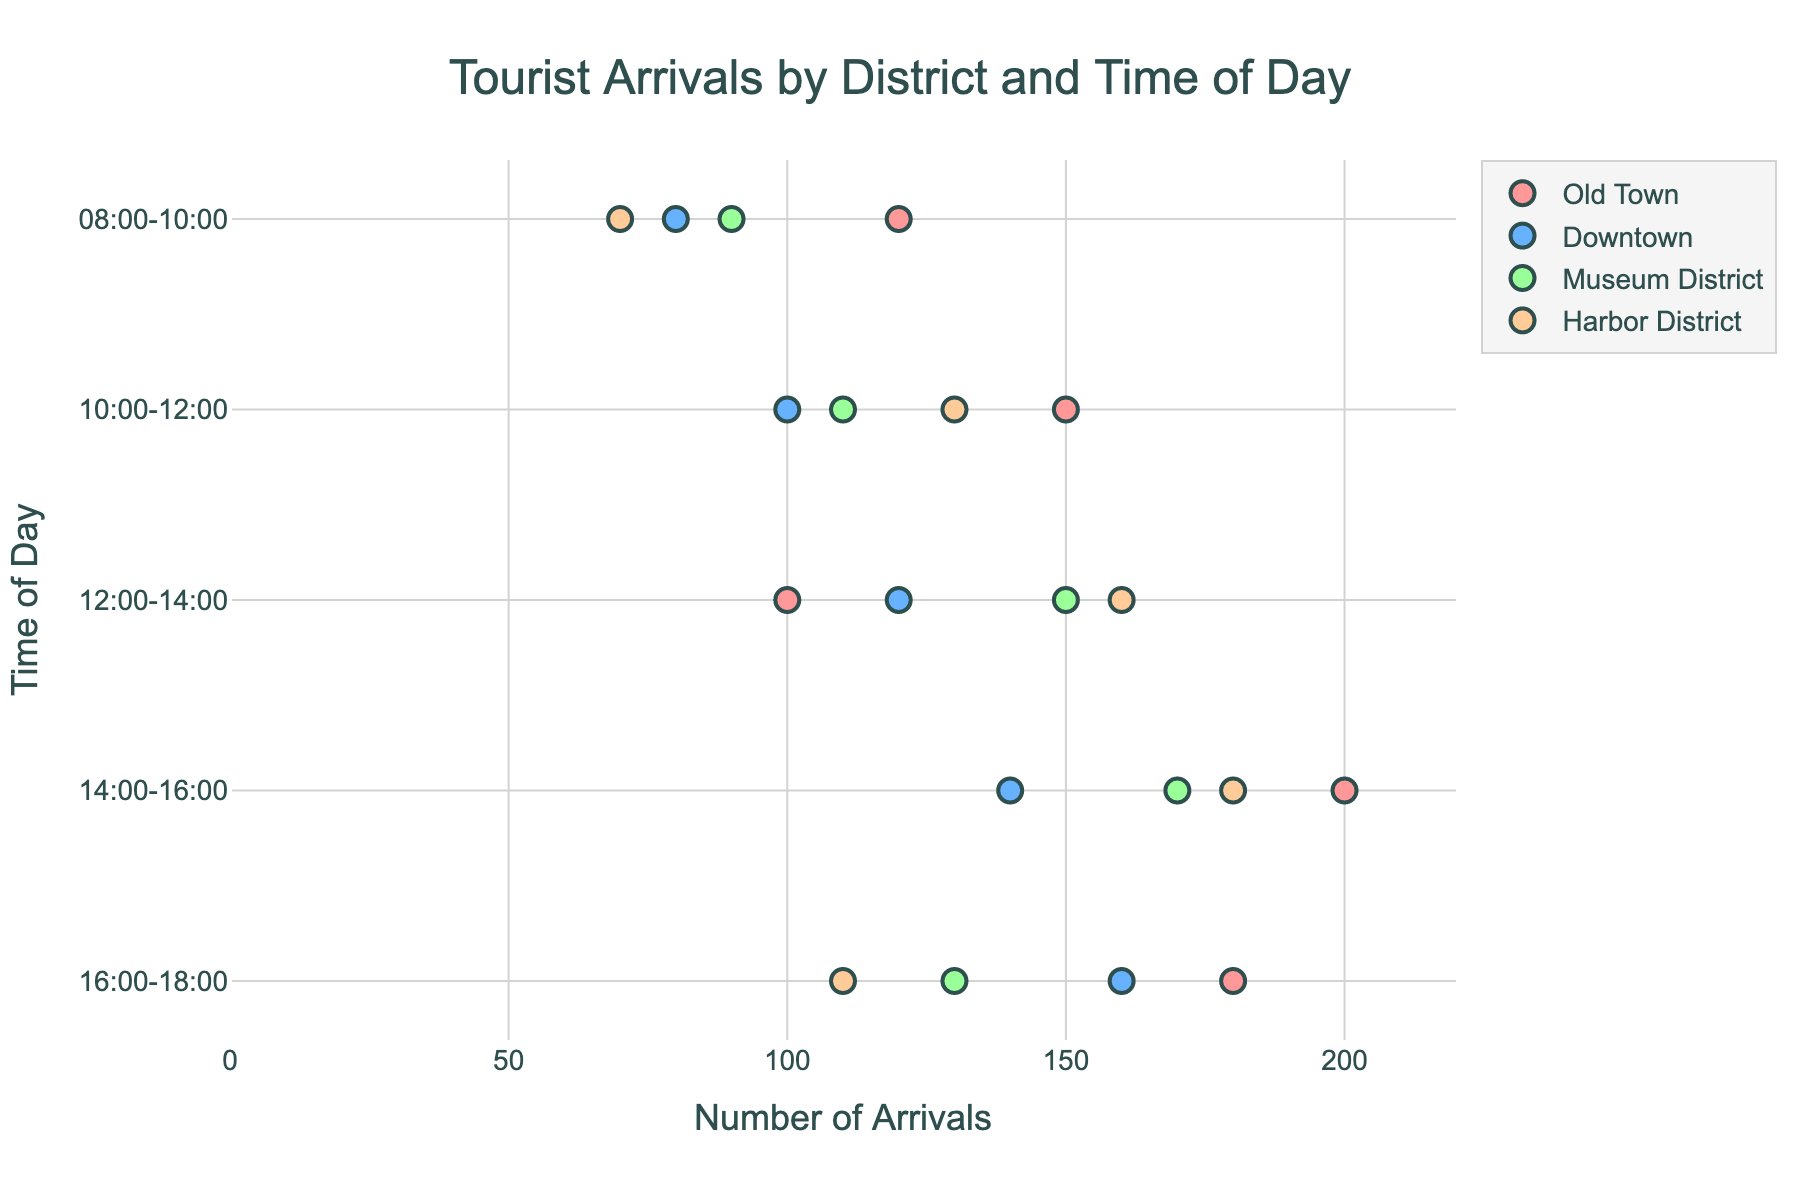What's the title of the plot? The plot's title is centered at the top of the figure and reads "Tourist Arrivals by District and Time of Day".
Answer: Tourist Arrivals by District and Time of Day How many districts are shown in the plot? The plot displays different colors for each district. By counting the number of different colors represented, we see four distinct districts: Old Town, Downtown, Museum District, and Harbor District.
Answer: 4 Which district had the highest number of tourist arrivals in the 14:00-16:00 time slot? Locate the data points corresponding to the 14:00-16:00 time slot on the y-axis. Compare the x-axis values for each district. The Old Town district has the highest arrival count with 200 arrivals.
Answer: Old Town What is the range of tourist arrivals in the Harbor District throughout the day? Look at all the points plotted for the Harbor District and identify the highest and lowest values. The highest is 180, and the lowest is 70, giving a range of 180 - 70.
Answer: 110 Which time of day has the greatest variation in tourist arrivals across all districts? Compare the spread of data points for each time slot. The 14:00-16:00 slot has the broadest variation, ranging from 140 (Downtown) to 200 (Old Town).
Answer: 14:00-16:00 What is the average number of arrivals in the Old Town district? Sum the arrivals for Old Town (120, 150, 100, 200, 180), which equals 750, then divide by the number of time slots (5).
Answer: 150 During which time slot does the Museum District see the highest number of tourist arrivals? Locate the highest data point for the Museum District by following the color representing this district. The highest arrival count of 170 occurs in the 14:00-16:00 slot.
Answer: 14:00-16:00 Which district has the lowest number of tourist arrivals in the 08:00-10:00 time slot? Identify the points for the 08:00-10:00 slot and compare them. The Harbor District has the lowest number of arrivals with 70.
Answer: Harbor District Between which two time slots does Old Town see the greatest increase in tourist arrivals? Compare the differences in arrival numbers between consecutive time slots for Old Town. The greatest increase is between 12:00-14:00 (100) and 14:00-16:00 (200), a difference of 100 arrivals.
Answer: 12:00-14:00 and 14:00-16:00 What is the combined number of tourist arrivals in the Downtown district across all time slots? Sum the arrivals for Downtown from all time slots: (80, 100, 120, 140, 160), which equals 600.
Answer: 600 